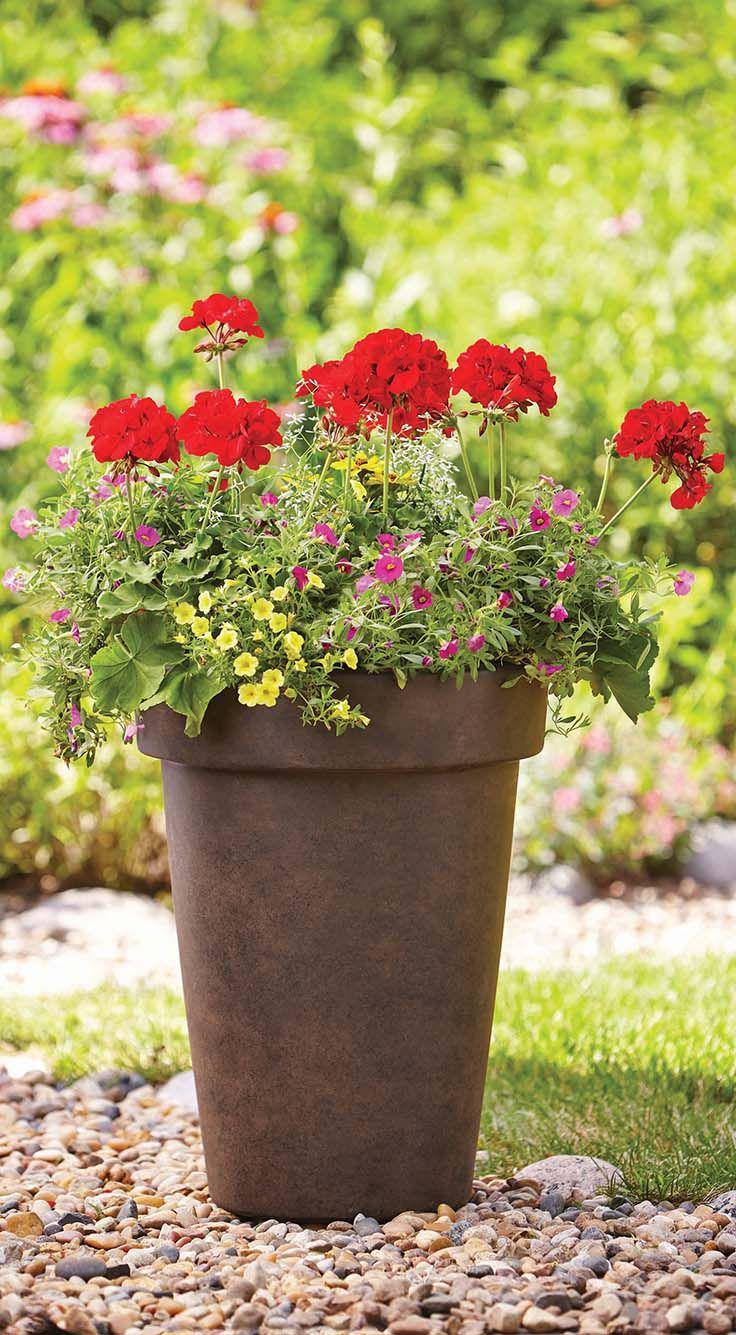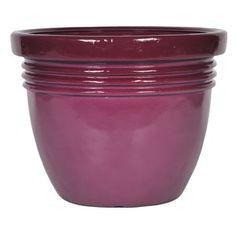The first image is the image on the left, the second image is the image on the right. For the images displayed, is the sentence "Each image contains one empty urn, and one of the urn models is footed, with a pedestal base." factually correct? Answer yes or no. No. The first image is the image on the left, the second image is the image on the right. For the images shown, is this caption "In one image, a flowering plant is shown in a tall planter pot outside" true? Answer yes or no. Yes. 